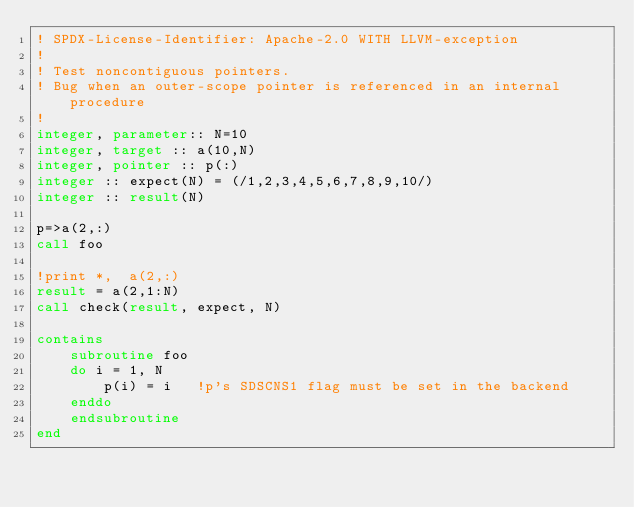Convert code to text. <code><loc_0><loc_0><loc_500><loc_500><_FORTRAN_>! SPDX-License-Identifier: Apache-2.0 WITH LLVM-exception
!
! Test noncontiguous pointers.
! Bug when an outer-scope pointer is referenced in an internal procedure
!
integer, parameter:: N=10
integer, target :: a(10,N)
integer, pointer :: p(:)
integer :: expect(N) = (/1,2,3,4,5,6,7,8,9,10/) 
integer :: result(N)

p=>a(2,:)
call foo

!print *,  a(2,:)
result = a(2,1:N)
call check(result, expect, N)

contains
    subroutine foo
    do i = 1, N
        p(i) = i   !p's SDSCNS1 flag must be set in the backend
    enddo
    endsubroutine
end
</code> 